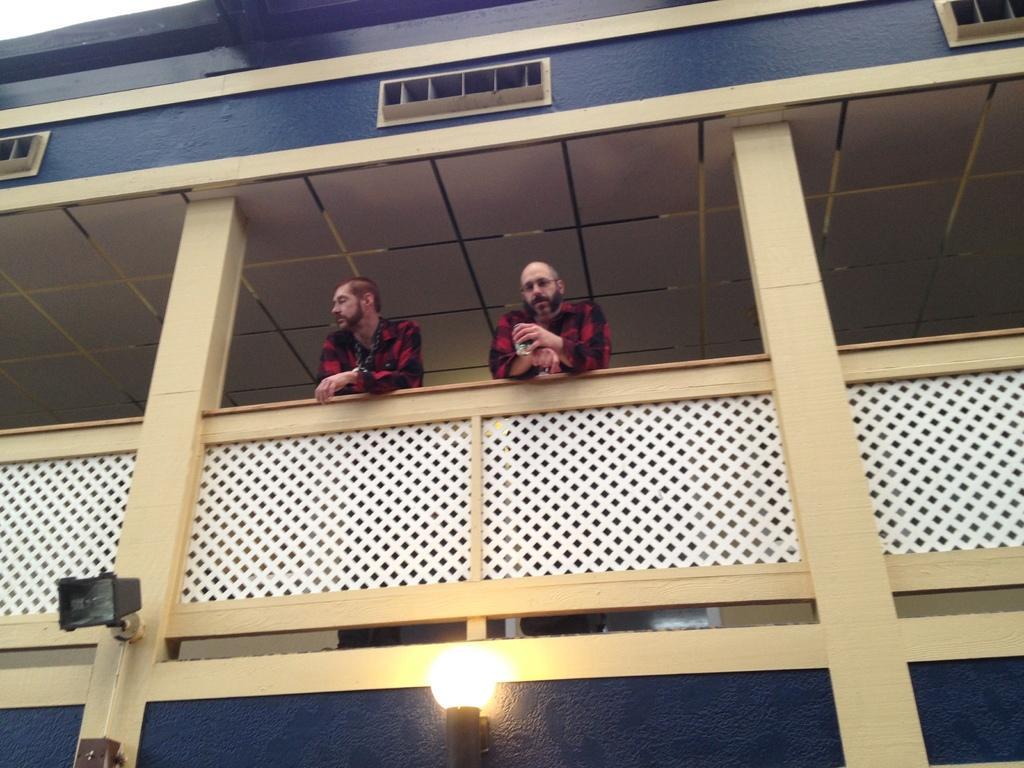Could you give a brief overview of what you see in this image? In this picture we can see there are two men standing in the balcony. At the bottom of the image, there are two lights attached to the wall of a building. 